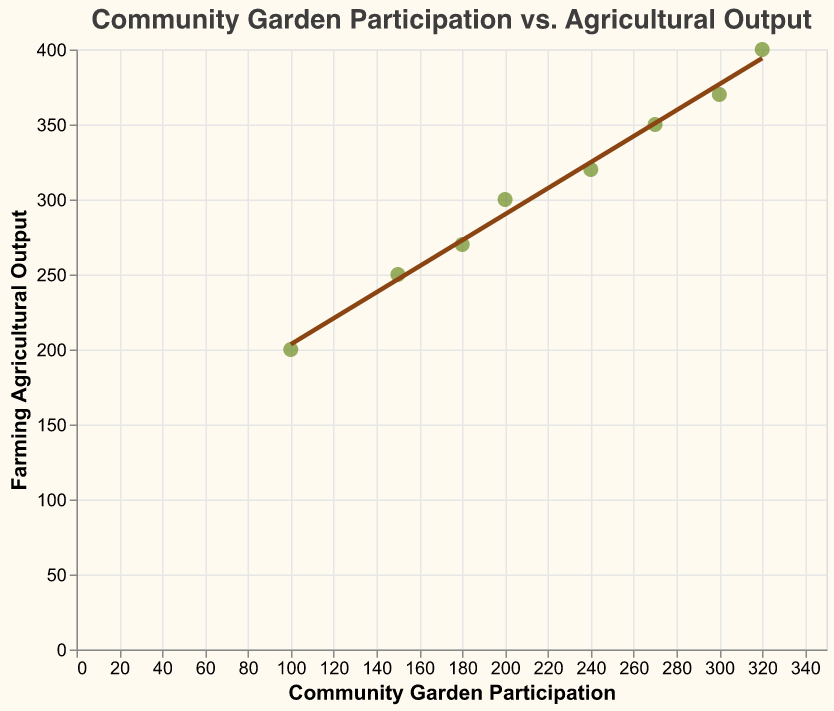How many data points are represented in the figure? By counting the points on the scatter plot, we can see there are 8 data points corresponding to each year from 2015 to 2022.
Answer: 8 What color represents the data points? The data points are represented with a filled green color (shade of olive green).
Answer: Green What is the title of the plot? The title of the plot is clearly mentioned on top and reads "Community Garden Participation vs. Agricultural Output".
Answer: Community Garden Participation vs. Agricultural Output What is the Farming Agricultural Output for the year 2021? From the tooltip or by identifying the data point at the intersection of "300" on the x-axis and corresponding point on the y-axis, we see the output for 2021 is 370.
Answer: 370 What trend can be observed from the scatter plot regarding community garden participation and agricultural output? The scatter plot with a trend line indicates a positive correlation, meaning as community garden participation increases, agricultural output also increases.
Answer: Positive correlation Which year showed the highest community garden participation? From the scatter plot, the highest community garden participation is 320, which corresponds to the year 2022.
Answer: 2022 How much did the farming agricultural output increase from 2015 to 2022? The farming agricultural output in 2015 was 200, and in 2022 it is 400. The increase is calculated as 400 - 200.
Answer: 200 Compare the agricultural output for the years 2017 and 2019. Which year had a higher output? From the scatter plot, the agricultural output for 2017 is 270 and for 2019 is 320. Comparing these, 2019 has a higher output.
Answer: 2019 What can be inferred about the slope of the trend line in the scatter plot? The trend line indicating the relationship between community garden participation and agricultural output has a positive slope, implying that as participation increases, output also tends to increase.
Answer: Positive slope If community garden participation were to increase to 340, what would be the estimated agricultural output based on the trend line? By extending the trend line and estimating the point where community garden participation is 340, the estimated agricultural output would align just above 400, likely around 410 or more.
Answer: Around 410 